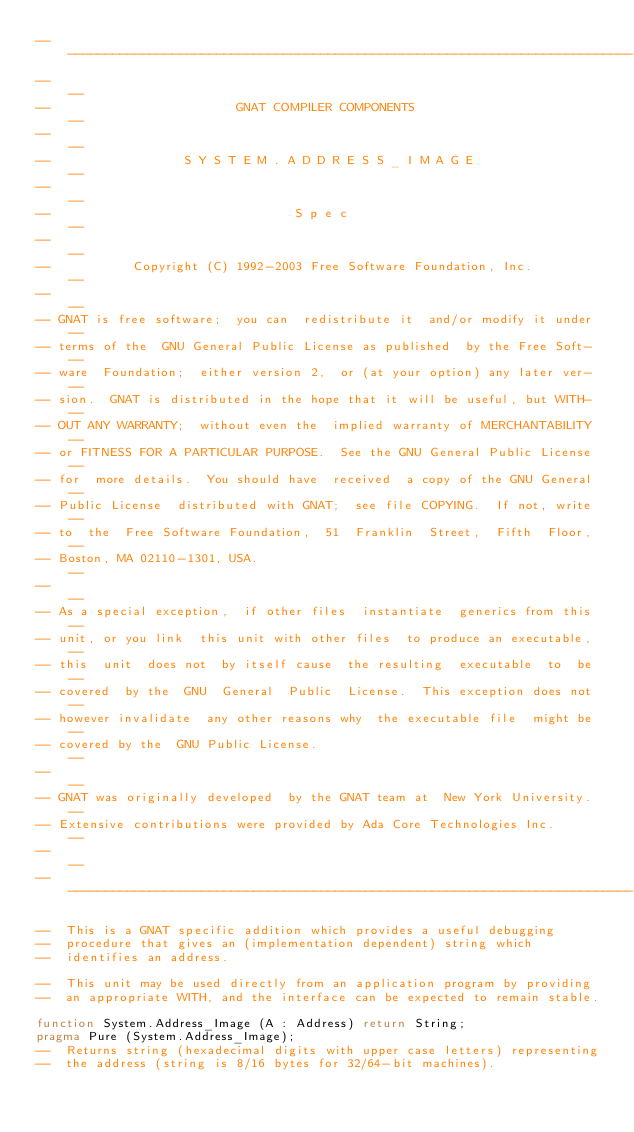<code> <loc_0><loc_0><loc_500><loc_500><_Ada_>------------------------------------------------------------------------------
--                                                                          --
--                         GNAT COMPILER COMPONENTS                         --
--                                                                          --
--                  S Y S T E M . A D D R E S S _ I M A G E                 --
--                                                                          --
--                                 S p e c                                  --
--                                                                          --
--           Copyright (C) 1992-2003 Free Software Foundation, Inc.         --
--                                                                          --
-- GNAT is free software;  you can  redistribute it  and/or modify it under --
-- terms of the  GNU General Public License as published  by the Free Soft- --
-- ware  Foundation;  either version 2,  or (at your option) any later ver- --
-- sion.  GNAT is distributed in the hope that it will be useful, but WITH- --
-- OUT ANY WARRANTY;  without even the  implied warranty of MERCHANTABILITY --
-- or FITNESS FOR A PARTICULAR PURPOSE.  See the GNU General Public License --
-- for  more details.  You should have  received  a copy of the GNU General --
-- Public License  distributed with GNAT;  see file COPYING.  If not, write --
-- to  the  Free Software Foundation,  51  Franklin  Street,  Fifth  Floor, --
-- Boston, MA 02110-1301, USA.                                              --
--                                                                          --
-- As a special exception,  if other files  instantiate  generics from this --
-- unit, or you link  this unit with other files  to produce an executable, --
-- this  unit  does not  by itself cause  the resulting  executable  to  be --
-- covered  by the  GNU  General  Public  License.  This exception does not --
-- however invalidate  any other reasons why  the executable file  might be --
-- covered by the  GNU Public License.                                      --
--                                                                          --
-- GNAT was originally developed  by the GNAT team at  New York University. --
-- Extensive contributions were provided by Ada Core Technologies Inc.      --
--                                                                          --
------------------------------------------------------------------------------

--  This is a GNAT specific addition which provides a useful debugging
--  procedure that gives an (implementation dependent) string which
--  identifies an address.

--  This unit may be used directly from an application program by providing
--  an appropriate WITH, and the interface can be expected to remain stable.

function System.Address_Image (A : Address) return String;
pragma Pure (System.Address_Image);
--  Returns string (hexadecimal digits with upper case letters) representing
--  the address (string is 8/16 bytes for 32/64-bit machines).
</code> 